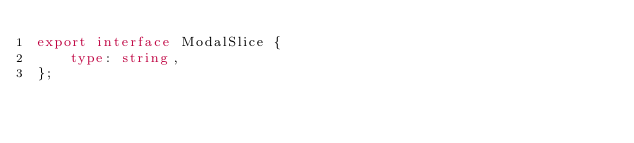<code> <loc_0><loc_0><loc_500><loc_500><_TypeScript_>export interface ModalSlice {
	type: string,
};
</code> 